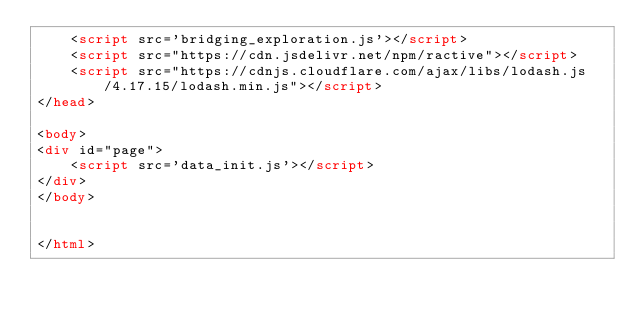Convert code to text. <code><loc_0><loc_0><loc_500><loc_500><_HTML_>	<script src='bridging_exploration.js'></script>
	<script src="https://cdn.jsdelivr.net/npm/ractive"></script>
	<script src="https://cdnjs.cloudflare.com/ajax/libs/lodash.js/4.17.15/lodash.min.js"></script>
</head>

<body>
<div id="page">
	<script src='data_init.js'></script>
</div>	
</body>


</html></code> 